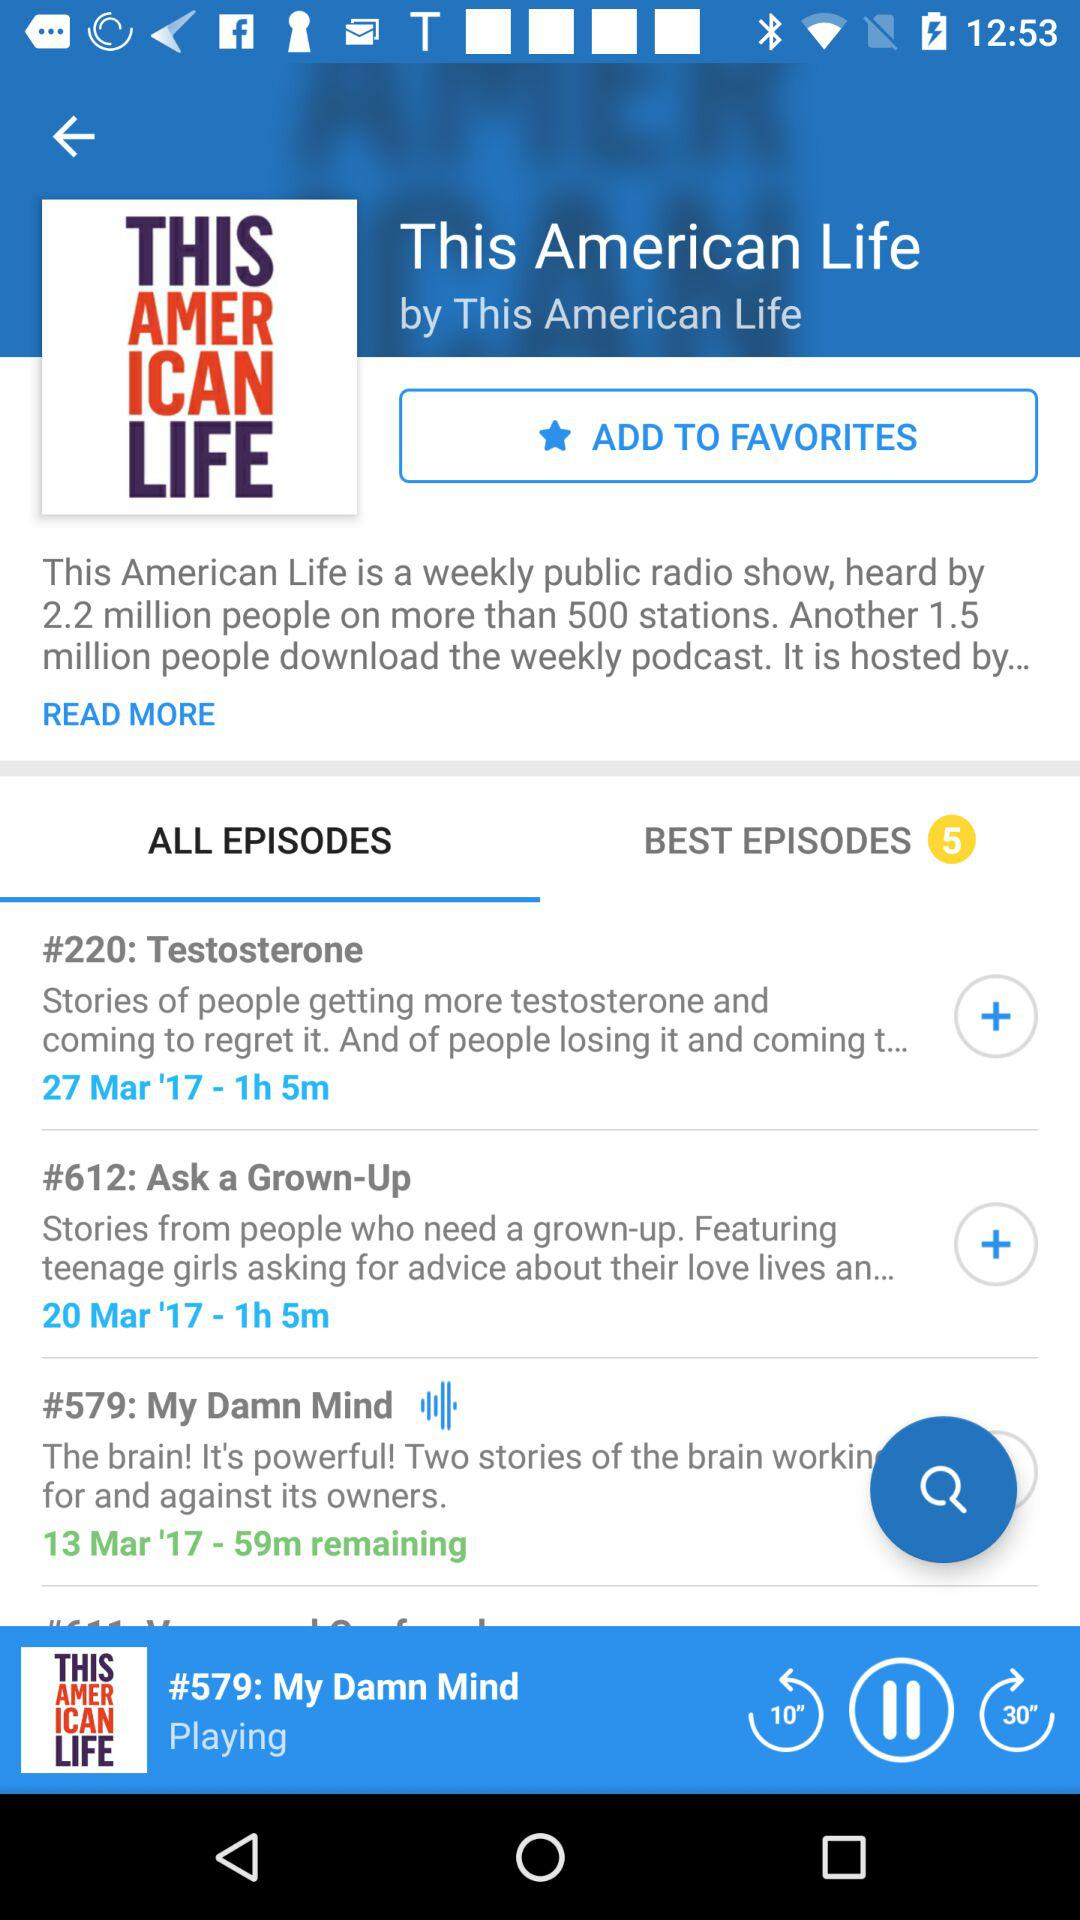How many episodes in total are in the "BEST EPISODES"? There are 5 episodes in the "BEST EPISODES". 